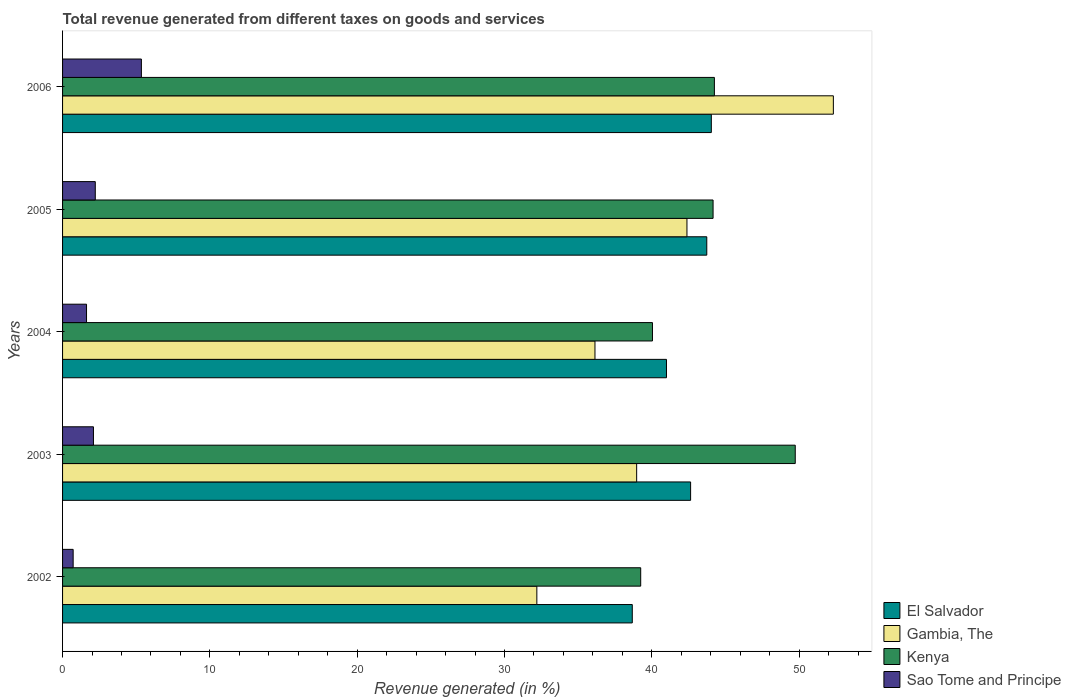How many different coloured bars are there?
Your answer should be compact. 4. Are the number of bars per tick equal to the number of legend labels?
Keep it short and to the point. Yes. Are the number of bars on each tick of the Y-axis equal?
Your response must be concise. Yes. How many bars are there on the 2nd tick from the top?
Offer a very short reply. 4. What is the label of the 5th group of bars from the top?
Give a very brief answer. 2002. In how many cases, is the number of bars for a given year not equal to the number of legend labels?
Make the answer very short. 0. What is the total revenue generated in Sao Tome and Principe in 2003?
Ensure brevity in your answer.  2.1. Across all years, what is the maximum total revenue generated in El Salvador?
Give a very brief answer. 44.04. Across all years, what is the minimum total revenue generated in El Salvador?
Provide a succinct answer. 38.67. In which year was the total revenue generated in Sao Tome and Principe maximum?
Your answer should be compact. 2006. In which year was the total revenue generated in El Salvador minimum?
Offer a terse response. 2002. What is the total total revenue generated in Sao Tome and Principe in the graph?
Make the answer very short. 12.01. What is the difference between the total revenue generated in El Salvador in 2002 and that in 2005?
Offer a very short reply. -5.06. What is the difference between the total revenue generated in Sao Tome and Principe in 2003 and the total revenue generated in El Salvador in 2002?
Make the answer very short. -36.58. What is the average total revenue generated in Gambia, The per year?
Your response must be concise. 40.4. In the year 2003, what is the difference between the total revenue generated in Sao Tome and Principe and total revenue generated in Kenya?
Provide a short and direct response. -47.64. What is the ratio of the total revenue generated in Kenya in 2004 to that in 2006?
Offer a very short reply. 0.91. What is the difference between the highest and the second highest total revenue generated in Kenya?
Your answer should be compact. 5.49. What is the difference between the highest and the lowest total revenue generated in Sao Tome and Principe?
Your answer should be compact. 4.63. Is it the case that in every year, the sum of the total revenue generated in Sao Tome and Principe and total revenue generated in Kenya is greater than the sum of total revenue generated in El Salvador and total revenue generated in Gambia, The?
Offer a very short reply. No. What does the 3rd bar from the top in 2004 represents?
Ensure brevity in your answer.  Gambia, The. What does the 1st bar from the bottom in 2005 represents?
Give a very brief answer. El Salvador. Is it the case that in every year, the sum of the total revenue generated in Kenya and total revenue generated in Gambia, The is greater than the total revenue generated in Sao Tome and Principe?
Provide a succinct answer. Yes. How many bars are there?
Keep it short and to the point. 20. How many years are there in the graph?
Provide a short and direct response. 5. What is the difference between two consecutive major ticks on the X-axis?
Offer a terse response. 10. Are the values on the major ticks of X-axis written in scientific E-notation?
Provide a succinct answer. No. How many legend labels are there?
Your answer should be very brief. 4. How are the legend labels stacked?
Your response must be concise. Vertical. What is the title of the graph?
Offer a terse response. Total revenue generated from different taxes on goods and services. Does "Mauritius" appear as one of the legend labels in the graph?
Your answer should be compact. No. What is the label or title of the X-axis?
Your response must be concise. Revenue generated (in %). What is the label or title of the Y-axis?
Offer a very short reply. Years. What is the Revenue generated (in %) in El Salvador in 2002?
Your answer should be compact. 38.67. What is the Revenue generated (in %) of Gambia, The in 2002?
Your response must be concise. 32.19. What is the Revenue generated (in %) of Kenya in 2002?
Offer a very short reply. 39.24. What is the Revenue generated (in %) of Sao Tome and Principe in 2002?
Your answer should be very brief. 0.72. What is the Revenue generated (in %) in El Salvador in 2003?
Give a very brief answer. 42.63. What is the Revenue generated (in %) in Gambia, The in 2003?
Offer a very short reply. 38.97. What is the Revenue generated (in %) in Kenya in 2003?
Ensure brevity in your answer.  49.74. What is the Revenue generated (in %) in Sao Tome and Principe in 2003?
Give a very brief answer. 2.1. What is the Revenue generated (in %) in El Salvador in 2004?
Your answer should be compact. 40.99. What is the Revenue generated (in %) of Gambia, The in 2004?
Offer a very short reply. 36.14. What is the Revenue generated (in %) in Kenya in 2004?
Provide a short and direct response. 40.04. What is the Revenue generated (in %) in Sao Tome and Principe in 2004?
Give a very brief answer. 1.63. What is the Revenue generated (in %) in El Salvador in 2005?
Keep it short and to the point. 43.73. What is the Revenue generated (in %) in Gambia, The in 2005?
Provide a succinct answer. 42.38. What is the Revenue generated (in %) in Kenya in 2005?
Offer a very short reply. 44.16. What is the Revenue generated (in %) of Sao Tome and Principe in 2005?
Your answer should be compact. 2.22. What is the Revenue generated (in %) in El Salvador in 2006?
Provide a succinct answer. 44.04. What is the Revenue generated (in %) of Gambia, The in 2006?
Your answer should be very brief. 52.32. What is the Revenue generated (in %) in Kenya in 2006?
Give a very brief answer. 44.25. What is the Revenue generated (in %) in Sao Tome and Principe in 2006?
Your answer should be very brief. 5.35. Across all years, what is the maximum Revenue generated (in %) in El Salvador?
Provide a short and direct response. 44.04. Across all years, what is the maximum Revenue generated (in %) in Gambia, The?
Keep it short and to the point. 52.32. Across all years, what is the maximum Revenue generated (in %) in Kenya?
Provide a short and direct response. 49.74. Across all years, what is the maximum Revenue generated (in %) of Sao Tome and Principe?
Provide a short and direct response. 5.35. Across all years, what is the minimum Revenue generated (in %) of El Salvador?
Your answer should be very brief. 38.67. Across all years, what is the minimum Revenue generated (in %) in Gambia, The?
Provide a short and direct response. 32.19. Across all years, what is the minimum Revenue generated (in %) of Kenya?
Offer a terse response. 39.24. Across all years, what is the minimum Revenue generated (in %) of Sao Tome and Principe?
Your response must be concise. 0.72. What is the total Revenue generated (in %) in El Salvador in the graph?
Your answer should be very brief. 210.07. What is the total Revenue generated (in %) in Gambia, The in the graph?
Give a very brief answer. 202.01. What is the total Revenue generated (in %) in Kenya in the graph?
Make the answer very short. 217.43. What is the total Revenue generated (in %) in Sao Tome and Principe in the graph?
Ensure brevity in your answer.  12.01. What is the difference between the Revenue generated (in %) in El Salvador in 2002 and that in 2003?
Your answer should be very brief. -3.96. What is the difference between the Revenue generated (in %) in Gambia, The in 2002 and that in 2003?
Ensure brevity in your answer.  -6.78. What is the difference between the Revenue generated (in %) in Kenya in 2002 and that in 2003?
Offer a very short reply. -10.49. What is the difference between the Revenue generated (in %) in Sao Tome and Principe in 2002 and that in 2003?
Your answer should be compact. -1.38. What is the difference between the Revenue generated (in %) in El Salvador in 2002 and that in 2004?
Your answer should be very brief. -2.32. What is the difference between the Revenue generated (in %) in Gambia, The in 2002 and that in 2004?
Your answer should be very brief. -3.95. What is the difference between the Revenue generated (in %) of Kenya in 2002 and that in 2004?
Make the answer very short. -0.8. What is the difference between the Revenue generated (in %) of Sao Tome and Principe in 2002 and that in 2004?
Your response must be concise. -0.91. What is the difference between the Revenue generated (in %) in El Salvador in 2002 and that in 2005?
Your response must be concise. -5.06. What is the difference between the Revenue generated (in %) in Gambia, The in 2002 and that in 2005?
Ensure brevity in your answer.  -10.19. What is the difference between the Revenue generated (in %) of Kenya in 2002 and that in 2005?
Ensure brevity in your answer.  -4.91. What is the difference between the Revenue generated (in %) in Sao Tome and Principe in 2002 and that in 2005?
Offer a terse response. -1.5. What is the difference between the Revenue generated (in %) of El Salvador in 2002 and that in 2006?
Provide a succinct answer. -5.37. What is the difference between the Revenue generated (in %) of Gambia, The in 2002 and that in 2006?
Keep it short and to the point. -20.13. What is the difference between the Revenue generated (in %) of Kenya in 2002 and that in 2006?
Provide a succinct answer. -5. What is the difference between the Revenue generated (in %) of Sao Tome and Principe in 2002 and that in 2006?
Your answer should be compact. -4.63. What is the difference between the Revenue generated (in %) of El Salvador in 2003 and that in 2004?
Make the answer very short. 1.64. What is the difference between the Revenue generated (in %) of Gambia, The in 2003 and that in 2004?
Offer a very short reply. 2.83. What is the difference between the Revenue generated (in %) of Kenya in 2003 and that in 2004?
Ensure brevity in your answer.  9.69. What is the difference between the Revenue generated (in %) of Sao Tome and Principe in 2003 and that in 2004?
Keep it short and to the point. 0.47. What is the difference between the Revenue generated (in %) in El Salvador in 2003 and that in 2005?
Offer a very short reply. -1.1. What is the difference between the Revenue generated (in %) of Gambia, The in 2003 and that in 2005?
Provide a succinct answer. -3.41. What is the difference between the Revenue generated (in %) of Kenya in 2003 and that in 2005?
Your answer should be very brief. 5.58. What is the difference between the Revenue generated (in %) in Sao Tome and Principe in 2003 and that in 2005?
Ensure brevity in your answer.  -0.12. What is the difference between the Revenue generated (in %) in El Salvador in 2003 and that in 2006?
Offer a very short reply. -1.41. What is the difference between the Revenue generated (in %) of Gambia, The in 2003 and that in 2006?
Offer a very short reply. -13.35. What is the difference between the Revenue generated (in %) of Kenya in 2003 and that in 2006?
Offer a very short reply. 5.49. What is the difference between the Revenue generated (in %) in Sao Tome and Principe in 2003 and that in 2006?
Provide a succinct answer. -3.25. What is the difference between the Revenue generated (in %) of El Salvador in 2004 and that in 2005?
Your answer should be very brief. -2.74. What is the difference between the Revenue generated (in %) in Gambia, The in 2004 and that in 2005?
Ensure brevity in your answer.  -6.24. What is the difference between the Revenue generated (in %) in Kenya in 2004 and that in 2005?
Keep it short and to the point. -4.11. What is the difference between the Revenue generated (in %) in Sao Tome and Principe in 2004 and that in 2005?
Keep it short and to the point. -0.59. What is the difference between the Revenue generated (in %) of El Salvador in 2004 and that in 2006?
Give a very brief answer. -3.04. What is the difference between the Revenue generated (in %) in Gambia, The in 2004 and that in 2006?
Your answer should be compact. -16.18. What is the difference between the Revenue generated (in %) of Kenya in 2004 and that in 2006?
Provide a succinct answer. -4.2. What is the difference between the Revenue generated (in %) of Sao Tome and Principe in 2004 and that in 2006?
Provide a short and direct response. -3.72. What is the difference between the Revenue generated (in %) in El Salvador in 2005 and that in 2006?
Provide a succinct answer. -0.31. What is the difference between the Revenue generated (in %) in Gambia, The in 2005 and that in 2006?
Make the answer very short. -9.94. What is the difference between the Revenue generated (in %) in Kenya in 2005 and that in 2006?
Offer a terse response. -0.09. What is the difference between the Revenue generated (in %) in Sao Tome and Principe in 2005 and that in 2006?
Your answer should be compact. -3.13. What is the difference between the Revenue generated (in %) in El Salvador in 2002 and the Revenue generated (in %) in Gambia, The in 2003?
Your answer should be compact. -0.3. What is the difference between the Revenue generated (in %) in El Salvador in 2002 and the Revenue generated (in %) in Kenya in 2003?
Provide a short and direct response. -11.06. What is the difference between the Revenue generated (in %) in El Salvador in 2002 and the Revenue generated (in %) in Sao Tome and Principe in 2003?
Provide a short and direct response. 36.58. What is the difference between the Revenue generated (in %) in Gambia, The in 2002 and the Revenue generated (in %) in Kenya in 2003?
Keep it short and to the point. -17.54. What is the difference between the Revenue generated (in %) in Gambia, The in 2002 and the Revenue generated (in %) in Sao Tome and Principe in 2003?
Offer a very short reply. 30.1. What is the difference between the Revenue generated (in %) in Kenya in 2002 and the Revenue generated (in %) in Sao Tome and Principe in 2003?
Give a very brief answer. 37.15. What is the difference between the Revenue generated (in %) in El Salvador in 2002 and the Revenue generated (in %) in Gambia, The in 2004?
Your answer should be compact. 2.53. What is the difference between the Revenue generated (in %) of El Salvador in 2002 and the Revenue generated (in %) of Kenya in 2004?
Keep it short and to the point. -1.37. What is the difference between the Revenue generated (in %) of El Salvador in 2002 and the Revenue generated (in %) of Sao Tome and Principe in 2004?
Ensure brevity in your answer.  37.05. What is the difference between the Revenue generated (in %) in Gambia, The in 2002 and the Revenue generated (in %) in Kenya in 2004?
Make the answer very short. -7.85. What is the difference between the Revenue generated (in %) in Gambia, The in 2002 and the Revenue generated (in %) in Sao Tome and Principe in 2004?
Your answer should be very brief. 30.57. What is the difference between the Revenue generated (in %) of Kenya in 2002 and the Revenue generated (in %) of Sao Tome and Principe in 2004?
Ensure brevity in your answer.  37.62. What is the difference between the Revenue generated (in %) of El Salvador in 2002 and the Revenue generated (in %) of Gambia, The in 2005?
Make the answer very short. -3.71. What is the difference between the Revenue generated (in %) of El Salvador in 2002 and the Revenue generated (in %) of Kenya in 2005?
Keep it short and to the point. -5.48. What is the difference between the Revenue generated (in %) of El Salvador in 2002 and the Revenue generated (in %) of Sao Tome and Principe in 2005?
Your answer should be very brief. 36.45. What is the difference between the Revenue generated (in %) in Gambia, The in 2002 and the Revenue generated (in %) in Kenya in 2005?
Provide a short and direct response. -11.96. What is the difference between the Revenue generated (in %) in Gambia, The in 2002 and the Revenue generated (in %) in Sao Tome and Principe in 2005?
Your answer should be compact. 29.97. What is the difference between the Revenue generated (in %) of Kenya in 2002 and the Revenue generated (in %) of Sao Tome and Principe in 2005?
Keep it short and to the point. 37.02. What is the difference between the Revenue generated (in %) of El Salvador in 2002 and the Revenue generated (in %) of Gambia, The in 2006?
Provide a succinct answer. -13.65. What is the difference between the Revenue generated (in %) of El Salvador in 2002 and the Revenue generated (in %) of Kenya in 2006?
Your response must be concise. -5.57. What is the difference between the Revenue generated (in %) of El Salvador in 2002 and the Revenue generated (in %) of Sao Tome and Principe in 2006?
Provide a succinct answer. 33.32. What is the difference between the Revenue generated (in %) in Gambia, The in 2002 and the Revenue generated (in %) in Kenya in 2006?
Give a very brief answer. -12.05. What is the difference between the Revenue generated (in %) of Gambia, The in 2002 and the Revenue generated (in %) of Sao Tome and Principe in 2006?
Offer a terse response. 26.84. What is the difference between the Revenue generated (in %) in Kenya in 2002 and the Revenue generated (in %) in Sao Tome and Principe in 2006?
Offer a very short reply. 33.89. What is the difference between the Revenue generated (in %) of El Salvador in 2003 and the Revenue generated (in %) of Gambia, The in 2004?
Your answer should be very brief. 6.49. What is the difference between the Revenue generated (in %) in El Salvador in 2003 and the Revenue generated (in %) in Kenya in 2004?
Offer a very short reply. 2.59. What is the difference between the Revenue generated (in %) in El Salvador in 2003 and the Revenue generated (in %) in Sao Tome and Principe in 2004?
Keep it short and to the point. 41.01. What is the difference between the Revenue generated (in %) of Gambia, The in 2003 and the Revenue generated (in %) of Kenya in 2004?
Give a very brief answer. -1.07. What is the difference between the Revenue generated (in %) of Gambia, The in 2003 and the Revenue generated (in %) of Sao Tome and Principe in 2004?
Provide a succinct answer. 37.34. What is the difference between the Revenue generated (in %) of Kenya in 2003 and the Revenue generated (in %) of Sao Tome and Principe in 2004?
Keep it short and to the point. 48.11. What is the difference between the Revenue generated (in %) in El Salvador in 2003 and the Revenue generated (in %) in Gambia, The in 2005?
Give a very brief answer. 0.25. What is the difference between the Revenue generated (in %) in El Salvador in 2003 and the Revenue generated (in %) in Kenya in 2005?
Provide a short and direct response. -1.53. What is the difference between the Revenue generated (in %) of El Salvador in 2003 and the Revenue generated (in %) of Sao Tome and Principe in 2005?
Provide a short and direct response. 40.41. What is the difference between the Revenue generated (in %) of Gambia, The in 2003 and the Revenue generated (in %) of Kenya in 2005?
Give a very brief answer. -5.19. What is the difference between the Revenue generated (in %) in Gambia, The in 2003 and the Revenue generated (in %) in Sao Tome and Principe in 2005?
Offer a terse response. 36.75. What is the difference between the Revenue generated (in %) of Kenya in 2003 and the Revenue generated (in %) of Sao Tome and Principe in 2005?
Offer a terse response. 47.51. What is the difference between the Revenue generated (in %) in El Salvador in 2003 and the Revenue generated (in %) in Gambia, The in 2006?
Your answer should be compact. -9.69. What is the difference between the Revenue generated (in %) of El Salvador in 2003 and the Revenue generated (in %) of Kenya in 2006?
Your answer should be compact. -1.61. What is the difference between the Revenue generated (in %) of El Salvador in 2003 and the Revenue generated (in %) of Sao Tome and Principe in 2006?
Offer a terse response. 37.28. What is the difference between the Revenue generated (in %) of Gambia, The in 2003 and the Revenue generated (in %) of Kenya in 2006?
Provide a short and direct response. -5.28. What is the difference between the Revenue generated (in %) of Gambia, The in 2003 and the Revenue generated (in %) of Sao Tome and Principe in 2006?
Ensure brevity in your answer.  33.62. What is the difference between the Revenue generated (in %) in Kenya in 2003 and the Revenue generated (in %) in Sao Tome and Principe in 2006?
Offer a terse response. 44.38. What is the difference between the Revenue generated (in %) in El Salvador in 2004 and the Revenue generated (in %) in Gambia, The in 2005?
Your answer should be compact. -1.39. What is the difference between the Revenue generated (in %) of El Salvador in 2004 and the Revenue generated (in %) of Kenya in 2005?
Your answer should be very brief. -3.16. What is the difference between the Revenue generated (in %) of El Salvador in 2004 and the Revenue generated (in %) of Sao Tome and Principe in 2005?
Keep it short and to the point. 38.77. What is the difference between the Revenue generated (in %) of Gambia, The in 2004 and the Revenue generated (in %) of Kenya in 2005?
Provide a succinct answer. -8.02. What is the difference between the Revenue generated (in %) of Gambia, The in 2004 and the Revenue generated (in %) of Sao Tome and Principe in 2005?
Make the answer very short. 33.92. What is the difference between the Revenue generated (in %) in Kenya in 2004 and the Revenue generated (in %) in Sao Tome and Principe in 2005?
Offer a very short reply. 37.82. What is the difference between the Revenue generated (in %) in El Salvador in 2004 and the Revenue generated (in %) in Gambia, The in 2006?
Your response must be concise. -11.33. What is the difference between the Revenue generated (in %) of El Salvador in 2004 and the Revenue generated (in %) of Kenya in 2006?
Keep it short and to the point. -3.25. What is the difference between the Revenue generated (in %) of El Salvador in 2004 and the Revenue generated (in %) of Sao Tome and Principe in 2006?
Your answer should be compact. 35.64. What is the difference between the Revenue generated (in %) in Gambia, The in 2004 and the Revenue generated (in %) in Kenya in 2006?
Your response must be concise. -8.11. What is the difference between the Revenue generated (in %) in Gambia, The in 2004 and the Revenue generated (in %) in Sao Tome and Principe in 2006?
Offer a terse response. 30.79. What is the difference between the Revenue generated (in %) in Kenya in 2004 and the Revenue generated (in %) in Sao Tome and Principe in 2006?
Keep it short and to the point. 34.69. What is the difference between the Revenue generated (in %) of El Salvador in 2005 and the Revenue generated (in %) of Gambia, The in 2006?
Your answer should be compact. -8.59. What is the difference between the Revenue generated (in %) of El Salvador in 2005 and the Revenue generated (in %) of Kenya in 2006?
Keep it short and to the point. -0.52. What is the difference between the Revenue generated (in %) in El Salvador in 2005 and the Revenue generated (in %) in Sao Tome and Principe in 2006?
Make the answer very short. 38.38. What is the difference between the Revenue generated (in %) of Gambia, The in 2005 and the Revenue generated (in %) of Kenya in 2006?
Give a very brief answer. -1.86. What is the difference between the Revenue generated (in %) in Gambia, The in 2005 and the Revenue generated (in %) in Sao Tome and Principe in 2006?
Give a very brief answer. 37.03. What is the difference between the Revenue generated (in %) of Kenya in 2005 and the Revenue generated (in %) of Sao Tome and Principe in 2006?
Your answer should be very brief. 38.81. What is the average Revenue generated (in %) in El Salvador per year?
Offer a terse response. 42.01. What is the average Revenue generated (in %) in Gambia, The per year?
Your answer should be very brief. 40.4. What is the average Revenue generated (in %) in Kenya per year?
Keep it short and to the point. 43.49. What is the average Revenue generated (in %) of Sao Tome and Principe per year?
Offer a very short reply. 2.4. In the year 2002, what is the difference between the Revenue generated (in %) in El Salvador and Revenue generated (in %) in Gambia, The?
Offer a terse response. 6.48. In the year 2002, what is the difference between the Revenue generated (in %) in El Salvador and Revenue generated (in %) in Kenya?
Offer a very short reply. -0.57. In the year 2002, what is the difference between the Revenue generated (in %) in El Salvador and Revenue generated (in %) in Sao Tome and Principe?
Provide a short and direct response. 37.95. In the year 2002, what is the difference between the Revenue generated (in %) in Gambia, The and Revenue generated (in %) in Kenya?
Your answer should be very brief. -7.05. In the year 2002, what is the difference between the Revenue generated (in %) of Gambia, The and Revenue generated (in %) of Sao Tome and Principe?
Ensure brevity in your answer.  31.48. In the year 2002, what is the difference between the Revenue generated (in %) of Kenya and Revenue generated (in %) of Sao Tome and Principe?
Offer a terse response. 38.52. In the year 2003, what is the difference between the Revenue generated (in %) in El Salvador and Revenue generated (in %) in Gambia, The?
Ensure brevity in your answer.  3.66. In the year 2003, what is the difference between the Revenue generated (in %) in El Salvador and Revenue generated (in %) in Kenya?
Your answer should be very brief. -7.1. In the year 2003, what is the difference between the Revenue generated (in %) of El Salvador and Revenue generated (in %) of Sao Tome and Principe?
Your answer should be very brief. 40.54. In the year 2003, what is the difference between the Revenue generated (in %) of Gambia, The and Revenue generated (in %) of Kenya?
Ensure brevity in your answer.  -10.77. In the year 2003, what is the difference between the Revenue generated (in %) in Gambia, The and Revenue generated (in %) in Sao Tome and Principe?
Your response must be concise. 36.87. In the year 2003, what is the difference between the Revenue generated (in %) in Kenya and Revenue generated (in %) in Sao Tome and Principe?
Your answer should be compact. 47.64. In the year 2004, what is the difference between the Revenue generated (in %) of El Salvador and Revenue generated (in %) of Gambia, The?
Offer a terse response. 4.85. In the year 2004, what is the difference between the Revenue generated (in %) of El Salvador and Revenue generated (in %) of Kenya?
Make the answer very short. 0.95. In the year 2004, what is the difference between the Revenue generated (in %) in El Salvador and Revenue generated (in %) in Sao Tome and Principe?
Keep it short and to the point. 39.37. In the year 2004, what is the difference between the Revenue generated (in %) in Gambia, The and Revenue generated (in %) in Kenya?
Make the answer very short. -3.9. In the year 2004, what is the difference between the Revenue generated (in %) of Gambia, The and Revenue generated (in %) of Sao Tome and Principe?
Make the answer very short. 34.51. In the year 2004, what is the difference between the Revenue generated (in %) of Kenya and Revenue generated (in %) of Sao Tome and Principe?
Make the answer very short. 38.42. In the year 2005, what is the difference between the Revenue generated (in %) in El Salvador and Revenue generated (in %) in Gambia, The?
Make the answer very short. 1.35. In the year 2005, what is the difference between the Revenue generated (in %) in El Salvador and Revenue generated (in %) in Kenya?
Provide a succinct answer. -0.43. In the year 2005, what is the difference between the Revenue generated (in %) in El Salvador and Revenue generated (in %) in Sao Tome and Principe?
Ensure brevity in your answer.  41.51. In the year 2005, what is the difference between the Revenue generated (in %) in Gambia, The and Revenue generated (in %) in Kenya?
Keep it short and to the point. -1.77. In the year 2005, what is the difference between the Revenue generated (in %) of Gambia, The and Revenue generated (in %) of Sao Tome and Principe?
Your response must be concise. 40.16. In the year 2005, what is the difference between the Revenue generated (in %) of Kenya and Revenue generated (in %) of Sao Tome and Principe?
Your answer should be very brief. 41.94. In the year 2006, what is the difference between the Revenue generated (in %) in El Salvador and Revenue generated (in %) in Gambia, The?
Make the answer very short. -8.28. In the year 2006, what is the difference between the Revenue generated (in %) of El Salvador and Revenue generated (in %) of Kenya?
Your answer should be compact. -0.21. In the year 2006, what is the difference between the Revenue generated (in %) of El Salvador and Revenue generated (in %) of Sao Tome and Principe?
Your answer should be compact. 38.69. In the year 2006, what is the difference between the Revenue generated (in %) of Gambia, The and Revenue generated (in %) of Kenya?
Offer a terse response. 8.08. In the year 2006, what is the difference between the Revenue generated (in %) in Gambia, The and Revenue generated (in %) in Sao Tome and Principe?
Ensure brevity in your answer.  46.97. In the year 2006, what is the difference between the Revenue generated (in %) in Kenya and Revenue generated (in %) in Sao Tome and Principe?
Provide a succinct answer. 38.9. What is the ratio of the Revenue generated (in %) of El Salvador in 2002 to that in 2003?
Offer a very short reply. 0.91. What is the ratio of the Revenue generated (in %) in Gambia, The in 2002 to that in 2003?
Provide a succinct answer. 0.83. What is the ratio of the Revenue generated (in %) in Kenya in 2002 to that in 2003?
Keep it short and to the point. 0.79. What is the ratio of the Revenue generated (in %) in Sao Tome and Principe in 2002 to that in 2003?
Your answer should be very brief. 0.34. What is the ratio of the Revenue generated (in %) of El Salvador in 2002 to that in 2004?
Offer a very short reply. 0.94. What is the ratio of the Revenue generated (in %) of Gambia, The in 2002 to that in 2004?
Give a very brief answer. 0.89. What is the ratio of the Revenue generated (in %) in Sao Tome and Principe in 2002 to that in 2004?
Your answer should be compact. 0.44. What is the ratio of the Revenue generated (in %) in El Salvador in 2002 to that in 2005?
Keep it short and to the point. 0.88. What is the ratio of the Revenue generated (in %) in Gambia, The in 2002 to that in 2005?
Provide a succinct answer. 0.76. What is the ratio of the Revenue generated (in %) in Kenya in 2002 to that in 2005?
Ensure brevity in your answer.  0.89. What is the ratio of the Revenue generated (in %) of Sao Tome and Principe in 2002 to that in 2005?
Your answer should be very brief. 0.32. What is the ratio of the Revenue generated (in %) of El Salvador in 2002 to that in 2006?
Give a very brief answer. 0.88. What is the ratio of the Revenue generated (in %) in Gambia, The in 2002 to that in 2006?
Make the answer very short. 0.62. What is the ratio of the Revenue generated (in %) in Kenya in 2002 to that in 2006?
Offer a terse response. 0.89. What is the ratio of the Revenue generated (in %) in Sao Tome and Principe in 2002 to that in 2006?
Provide a short and direct response. 0.13. What is the ratio of the Revenue generated (in %) of El Salvador in 2003 to that in 2004?
Offer a very short reply. 1.04. What is the ratio of the Revenue generated (in %) in Gambia, The in 2003 to that in 2004?
Ensure brevity in your answer.  1.08. What is the ratio of the Revenue generated (in %) in Kenya in 2003 to that in 2004?
Keep it short and to the point. 1.24. What is the ratio of the Revenue generated (in %) in Sao Tome and Principe in 2003 to that in 2004?
Your answer should be very brief. 1.29. What is the ratio of the Revenue generated (in %) of El Salvador in 2003 to that in 2005?
Make the answer very short. 0.97. What is the ratio of the Revenue generated (in %) of Gambia, The in 2003 to that in 2005?
Provide a short and direct response. 0.92. What is the ratio of the Revenue generated (in %) in Kenya in 2003 to that in 2005?
Provide a succinct answer. 1.13. What is the ratio of the Revenue generated (in %) of Sao Tome and Principe in 2003 to that in 2005?
Ensure brevity in your answer.  0.94. What is the ratio of the Revenue generated (in %) in El Salvador in 2003 to that in 2006?
Your response must be concise. 0.97. What is the ratio of the Revenue generated (in %) in Gambia, The in 2003 to that in 2006?
Provide a short and direct response. 0.74. What is the ratio of the Revenue generated (in %) of Kenya in 2003 to that in 2006?
Your response must be concise. 1.12. What is the ratio of the Revenue generated (in %) in Sao Tome and Principe in 2003 to that in 2006?
Make the answer very short. 0.39. What is the ratio of the Revenue generated (in %) in El Salvador in 2004 to that in 2005?
Provide a succinct answer. 0.94. What is the ratio of the Revenue generated (in %) of Gambia, The in 2004 to that in 2005?
Your answer should be very brief. 0.85. What is the ratio of the Revenue generated (in %) of Kenya in 2004 to that in 2005?
Offer a terse response. 0.91. What is the ratio of the Revenue generated (in %) in Sao Tome and Principe in 2004 to that in 2005?
Keep it short and to the point. 0.73. What is the ratio of the Revenue generated (in %) in El Salvador in 2004 to that in 2006?
Provide a short and direct response. 0.93. What is the ratio of the Revenue generated (in %) in Gambia, The in 2004 to that in 2006?
Offer a very short reply. 0.69. What is the ratio of the Revenue generated (in %) of Kenya in 2004 to that in 2006?
Give a very brief answer. 0.91. What is the ratio of the Revenue generated (in %) in Sao Tome and Principe in 2004 to that in 2006?
Offer a terse response. 0.3. What is the ratio of the Revenue generated (in %) of Gambia, The in 2005 to that in 2006?
Keep it short and to the point. 0.81. What is the ratio of the Revenue generated (in %) in Kenya in 2005 to that in 2006?
Offer a very short reply. 1. What is the ratio of the Revenue generated (in %) of Sao Tome and Principe in 2005 to that in 2006?
Give a very brief answer. 0.41. What is the difference between the highest and the second highest Revenue generated (in %) of El Salvador?
Keep it short and to the point. 0.31. What is the difference between the highest and the second highest Revenue generated (in %) in Gambia, The?
Your answer should be compact. 9.94. What is the difference between the highest and the second highest Revenue generated (in %) in Kenya?
Your answer should be very brief. 5.49. What is the difference between the highest and the second highest Revenue generated (in %) of Sao Tome and Principe?
Offer a very short reply. 3.13. What is the difference between the highest and the lowest Revenue generated (in %) of El Salvador?
Provide a succinct answer. 5.37. What is the difference between the highest and the lowest Revenue generated (in %) in Gambia, The?
Make the answer very short. 20.13. What is the difference between the highest and the lowest Revenue generated (in %) of Kenya?
Ensure brevity in your answer.  10.49. What is the difference between the highest and the lowest Revenue generated (in %) in Sao Tome and Principe?
Your response must be concise. 4.63. 